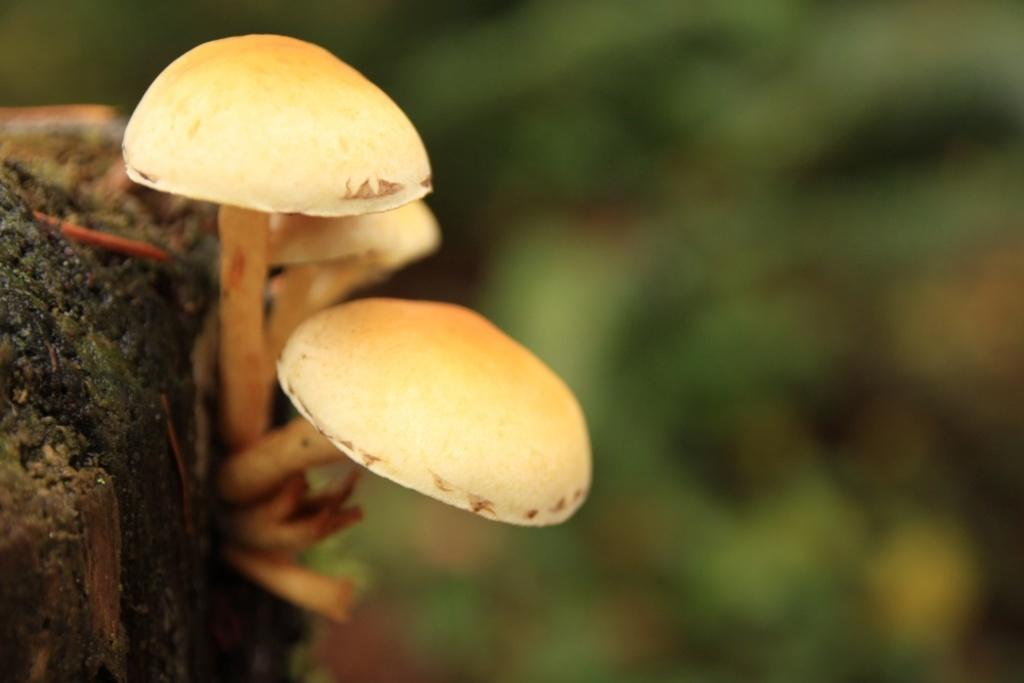What type of vegetation is present in the image? There are mushrooms in the image. Can you describe the background of the image? The background of the image is blurry. What type of pain can be seen in the image? There is no pain present in the image; it features mushrooms and a blurry background. What sound can be heard coming from the mushrooms in the image? There is no sound associated with the mushrooms in the image, as they are not capable of producing sound. 